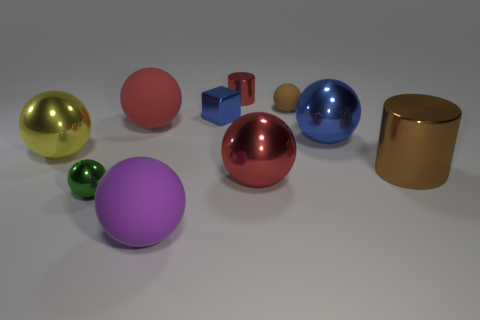Subtract 4 spheres. How many spheres are left? 3 Subtract all purple spheres. How many spheres are left? 6 Subtract all red shiny spheres. How many spheres are left? 6 Subtract all green spheres. Subtract all cyan cylinders. How many spheres are left? 6 Subtract all blocks. How many objects are left? 9 Add 1 small matte balls. How many small matte balls are left? 2 Add 6 red things. How many red things exist? 9 Subtract 0 yellow cylinders. How many objects are left? 10 Subtract all yellow things. Subtract all tiny purple shiny cylinders. How many objects are left? 9 